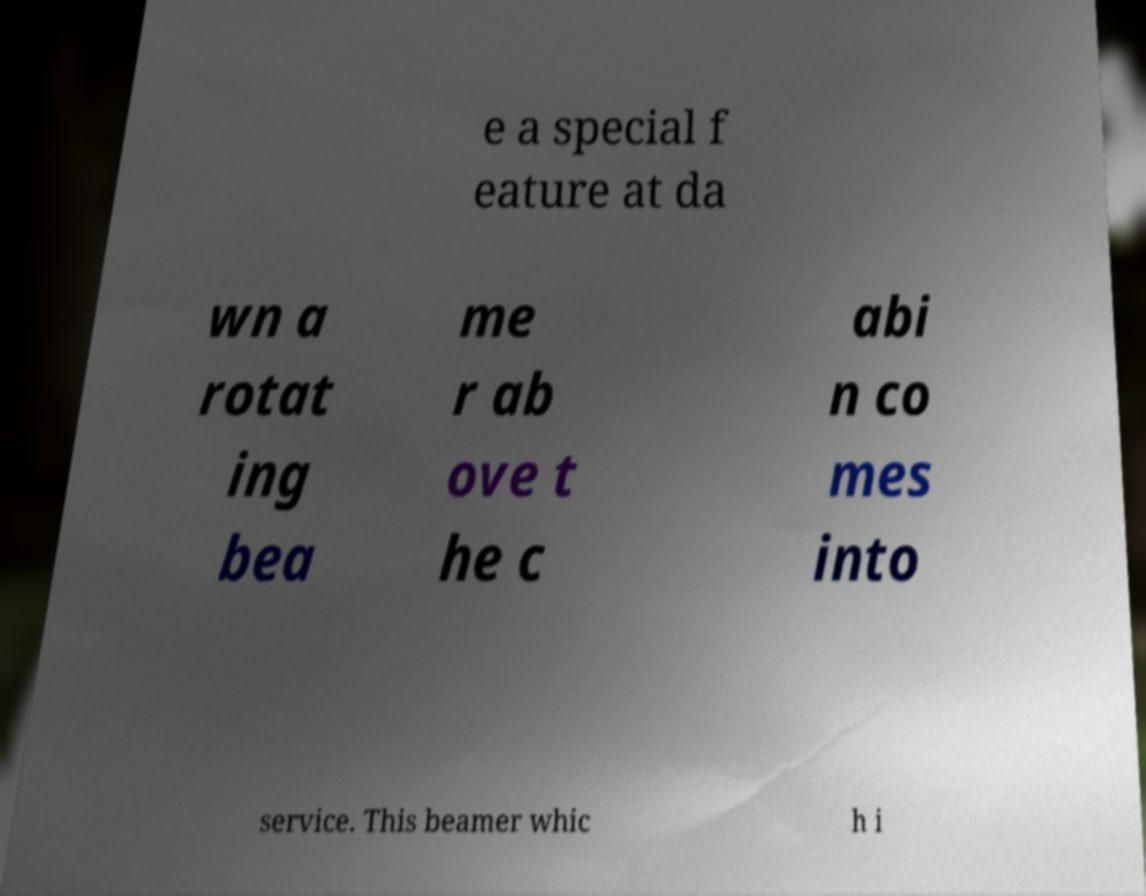Please read and relay the text visible in this image. What does it say? e a special f eature at da wn a rotat ing bea me r ab ove t he c abi n co mes into service. This beamer whic h i 